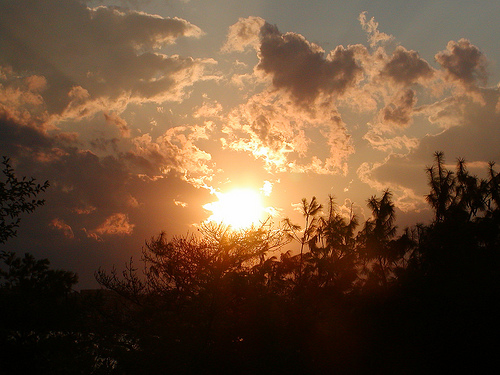<image>
Is the sun behind the clouds? Yes. From this viewpoint, the sun is positioned behind the clouds, with the clouds partially or fully occluding the sun. 